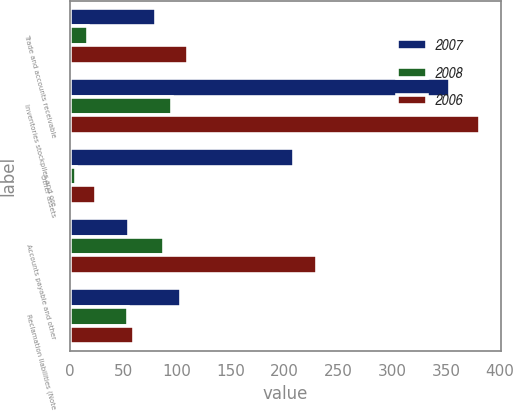Convert chart. <chart><loc_0><loc_0><loc_500><loc_500><stacked_bar_chart><ecel><fcel>Trade and accounts receivable<fcel>Inventories stockpiles and ore<fcel>Other assets<fcel>Accounts payable and other<fcel>Reclamation liabilities (Note<nl><fcel>2007<fcel>80<fcel>354<fcel>209<fcel>55<fcel>104<nl><fcel>2008<fcel>17<fcel>95<fcel>6<fcel>87.5<fcel>54<nl><fcel>2006<fcel>110<fcel>382<fcel>25<fcel>230<fcel>60<nl></chart> 